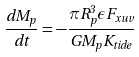<formula> <loc_0><loc_0><loc_500><loc_500>\frac { d M _ { p } } { d t } = - \frac { \pi R _ { p } ^ { 3 } \epsilon F _ { x u v } } { G M _ { p } K _ { t i d e } }</formula> 